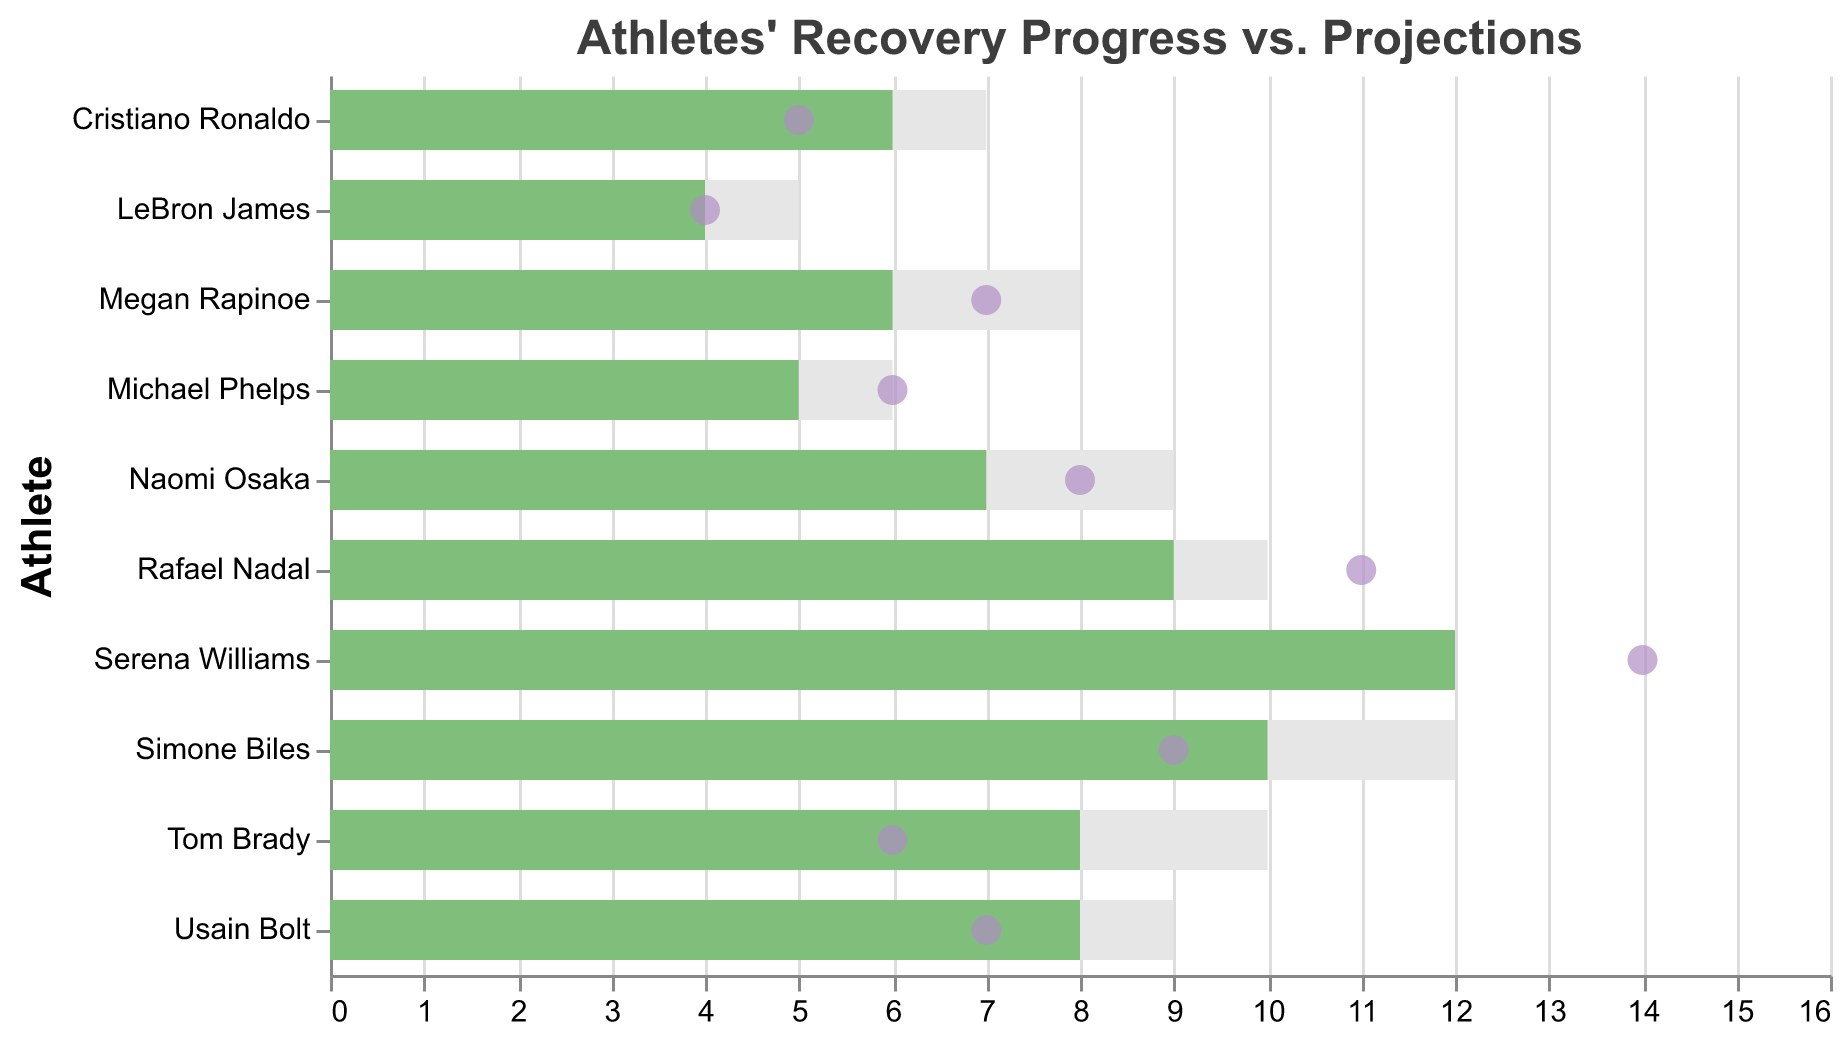What is the title of the chart? The title of the chart is displayed at the top and specifies the purpose or focus of the chart.
Answer: Athletes' Recovery Progress vs. Projections Which athlete had the fastest recovery? To find the athlete with the fastest recovery, look for the shortest "Actual Recovery (weeks)" which is represented by a point.
Answer: Cristiano Ronaldo How many athletes recovered faster than the league average? Count the points (representing actual recovery) that are to the left of their respective "League Average (weeks)" bar.
Answer: Five Which athlete took longer than the projected recovery time? Compare the position of the point (actual recovery) with the corresponding bar (projected recovery). If the point is to the right of the bar, the athlete took longer.
Answer: Serena Williams, Megan Rapinoe, Naomi Osaka, Rafael Nadal What is the average projected recovery time for all athletes? Add up all projected recovery times and divide by the number of athletes: (8+12+6+10+4+6+8+5+7+9) / 10 = 75 / 10.
Answer: 7.5 weeks Which athlete matched their projected recovery time exactly? Look for the point that aligns perfectly with its respective projected recovery bar.
Answer: LeBron James How many weeks did Usain Bolt recover faster than the projected time? Subtract Usain's actual recovery time from his projected recovery time: 8 - 7.
Answer: 1 week Which athlete’s recovery time was closest to the league average? Compare the points' distances from the league average bars for each athlete to find the shortest distance.
Answer: Michael Phelps What is the difference between Serena Williams' actual recovery time and the league average? Subtract the league average from Serena's actual recovery time: 14 - 11.
Answer: 3 weeks How does Rafael Nadal's actual recovery time compare with Cristiano Ronaldo’s? Compare the points' position on the x-axis for Rafael Nadal and Cristiano Ronaldo: 11 weeks vs 5 weeks.
Answer: Rafael Nadal took longer by 6 weeks 